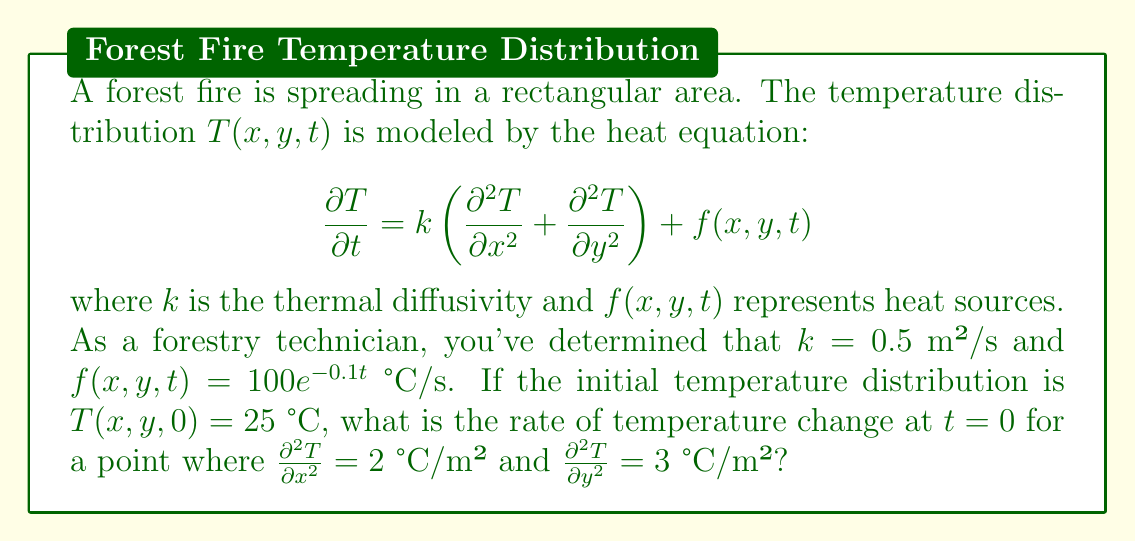Give your solution to this math problem. To solve this problem, we'll follow these steps:

1) We start with the heat equation:

   $$\frac{\partial T}{\partial t} = k\left(\frac{\partial^2 T}{\partial x^2} + \frac{\partial^2 T}{\partial y^2}\right) + f(x,y,t)$$

2) We're given that:
   - $k = 0.5$ m²/s
   - $f(x,y,t) = 100e^{-0.1t}$ °C/s
   - At the point of interest: $\frac{\partial^2 T}{\partial x^2} = 2$ °C/m² and $\frac{\partial^2 T}{\partial y^2} = 3$ °C/m²
   - We need to find $\frac{\partial T}{\partial t}$ at $t = 0$

3) Let's substitute these values into the equation:

   $$\frac{\partial T}{\partial t} = 0.5\left(2 + 3\right) + 100e^{-0.1(0)}$$

4) Simplify:
   
   $$\frac{\partial T}{\partial t} = 0.5(5) + 100$$

5) Calculate:

   $$\frac{\partial T}{\partial t} = 2.5 + 100 = 102.5$$

Therefore, at $t = 0$, the rate of temperature change is 102.5 °C/s.
Answer: 102.5 °C/s 